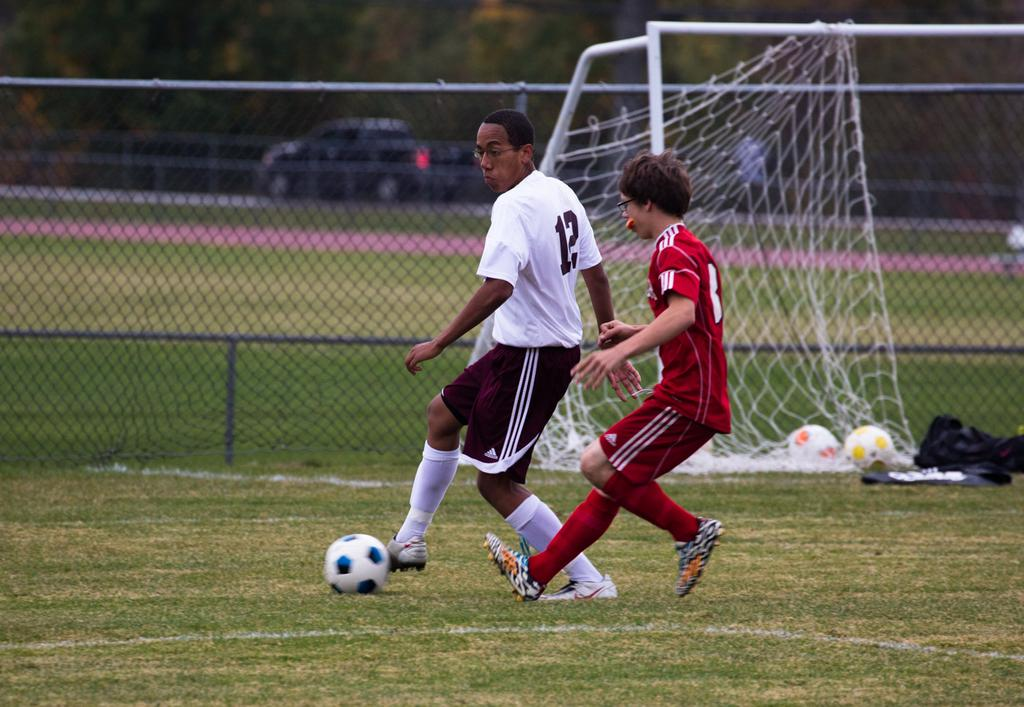<image>
Share a concise interpretation of the image provided. Player number 12 is trying to keep the ball from the red clad opponent. 